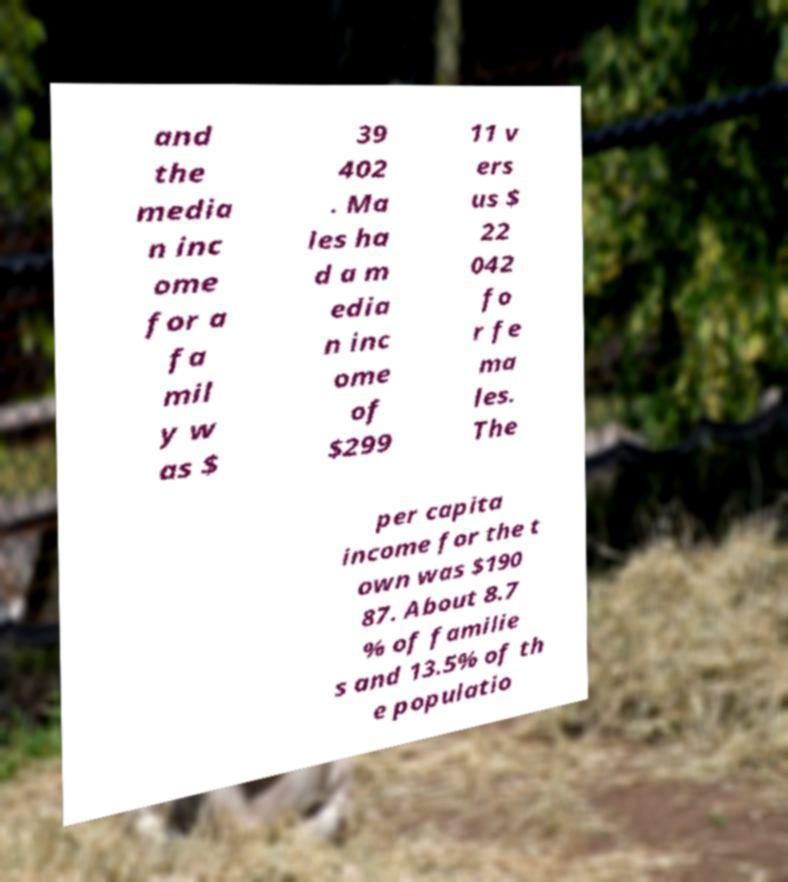Could you assist in decoding the text presented in this image and type it out clearly? and the media n inc ome for a fa mil y w as $ 39 402 . Ma les ha d a m edia n inc ome of $299 11 v ers us $ 22 042 fo r fe ma les. The per capita income for the t own was $190 87. About 8.7 % of familie s and 13.5% of th e populatio 